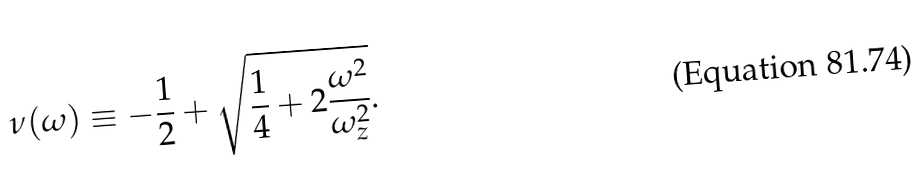<formula> <loc_0><loc_0><loc_500><loc_500>\nu ( \omega ) \equiv - \frac { 1 } { 2 } + \sqrt { \frac { 1 } { 4 } + 2 \frac { \omega ^ { 2 } } { \omega _ { z } ^ { 2 } } } .</formula> 